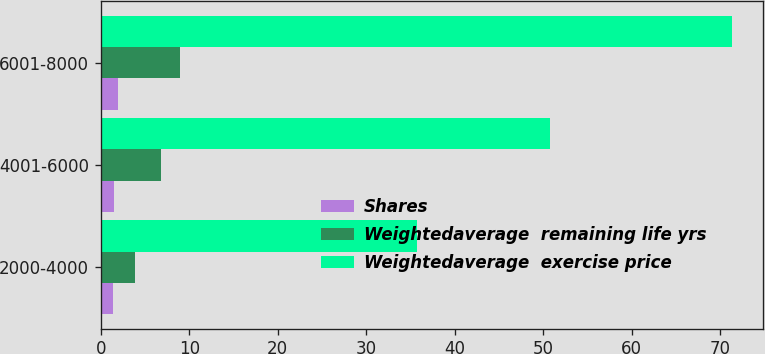<chart> <loc_0><loc_0><loc_500><loc_500><stacked_bar_chart><ecel><fcel>2000-4000<fcel>4001-6000<fcel>6001-8000<nl><fcel>Shares<fcel>1.4<fcel>1.5<fcel>1.9<nl><fcel>Weightedaverage  remaining life yrs<fcel>3.9<fcel>6.8<fcel>8.9<nl><fcel>Weightedaverage  exercise price<fcel>35.71<fcel>50.77<fcel>71.33<nl></chart> 